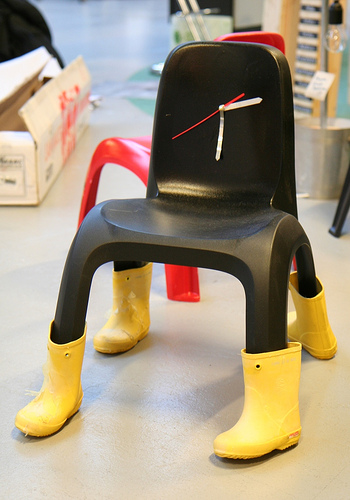<image>Who made this chair for children? It is unknown who made this chair for children. Who made this chair for children? It is unanswerable who made this chair for children. 